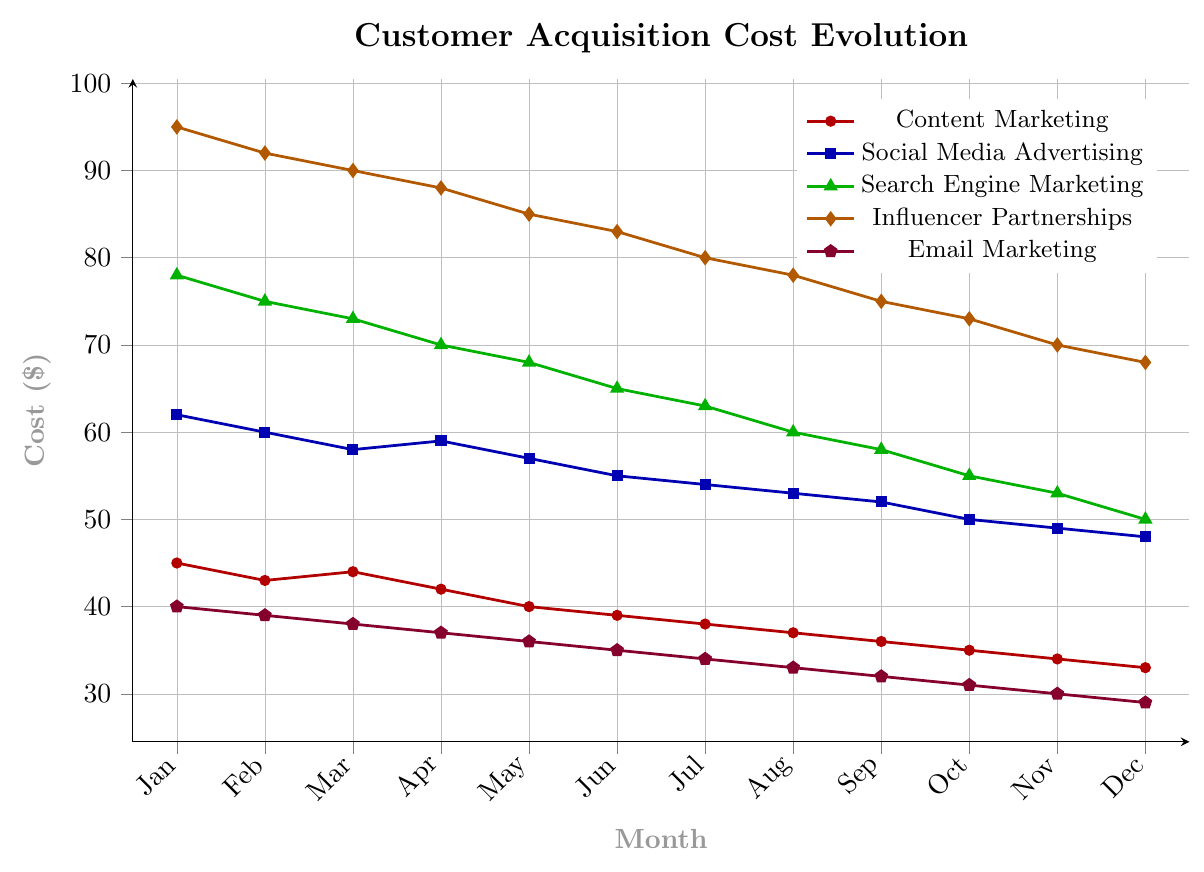What's the trend for the customer acquisition cost of Content Marketing over the past year? In the chart, the red line represents the cost of Content Marketing. It starts high in January at $45 and declines steadily to $33 in December. So, the trend is a consistent decrease.
Answer: Decreasing In which month was the customer acquisition cost for Influencer Partnerships the highest? The orange line indicates the cost for Influencer Partnerships. The cost starts at $95 in January and shows a constant decrease. The highest value is $95 in January.
Answer: January What is the difference in customer acquisition cost between Social Media Advertising and Email Marketing in March? In March, Social Media Advertising (blue line) has a cost of $58, while Email Marketing (purple line) has a cost of $38. The difference is calculated as $58 - $38 = $20.
Answer: $20 Which marketing strategy had the lowest customer acquisition cost in December? In December, the purple line (Email Marketing) reaches $29, which is the lowest value among all strategies.
Answer: Email Marketing How much did the customer acquisition cost for Search Engine Marketing decrease from January to December? The green line represents Search Engine Marketing costs. It starts at $78 in January and drops to $50 in December. The decrease is $78 - $50 = $28.
Answer: $28 Compare the cost trajectories for Social Media Advertising and Influencer Partnerships over the year. Which one shows a steeper decline? Social Media Advertising (blue line) starts at $62 and ends at $48, a decrease of $14. Influencer Partnerships (orange line) starts at $95 and ends at $68, a decrease of $27. The decline for Influencer Partnerships is more pronounced.
Answer: Influencer Partnerships What is the average customer acquisition cost for Email Marketing over the entire year? We need to add the costs for each month and divide by 12. The values for each month are: 40, 39, 38, 37, 36, 35, 34, 33, 32, 31, 30, 29. Sum these values: 40 + 39 + 38 + 37 + 36 + 35 + 34 + 33 + 32 + 31 + 30 + 29 = 414. The average is 414 / 12 = 34.5.
Answer: $34.5 During which month did all marketing strategies demonstrate the same trend (either all decreasing or all increasing)? Observing the lines for all five strategies, we find that only between January to December, all lines show a consistent decreasing trend.
Answer: January to December Which month saw the smallest gap between the highest and lowest customer acquisition cost? By examining the lines, November has the smallest gap. In November, Influencer Partnerships is at $70 (highest) and Email Marketing is at $30 (lowest). The gap is $70 - $30 = $40, which is the smallest gap throughout the year.
Answer: November 